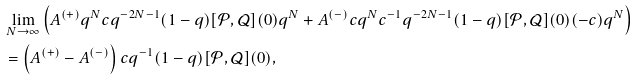Convert formula to latex. <formula><loc_0><loc_0><loc_500><loc_500>& \lim _ { N \to \infty } \left ( A ^ { ( + ) } q ^ { N } c q ^ { - 2 N - 1 } ( 1 - q ) [ \mathcal { P } , \mathcal { Q } ] ( 0 ) q ^ { N } + A ^ { ( - ) } c q ^ { N } c ^ { - 1 } q ^ { - 2 N - 1 } ( 1 - q ) [ \mathcal { P } , \mathcal { Q } ] ( 0 ) ( - c ) q ^ { N } \right ) \\ & = \left ( A ^ { ( + ) } - A ^ { ( - ) } \right ) c q ^ { - 1 } ( 1 - q ) [ \mathcal { P } , \mathcal { Q } ] ( 0 ) ,</formula> 